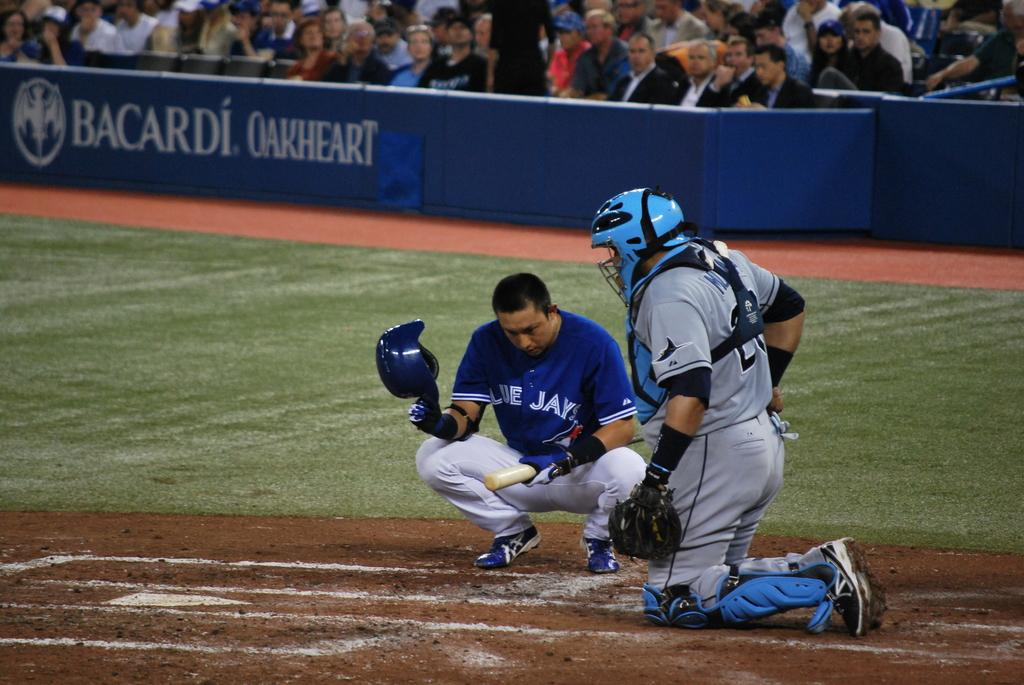<image>
Describe the image concisely. The BlueJays umpire and catcher crouch down on the ground 